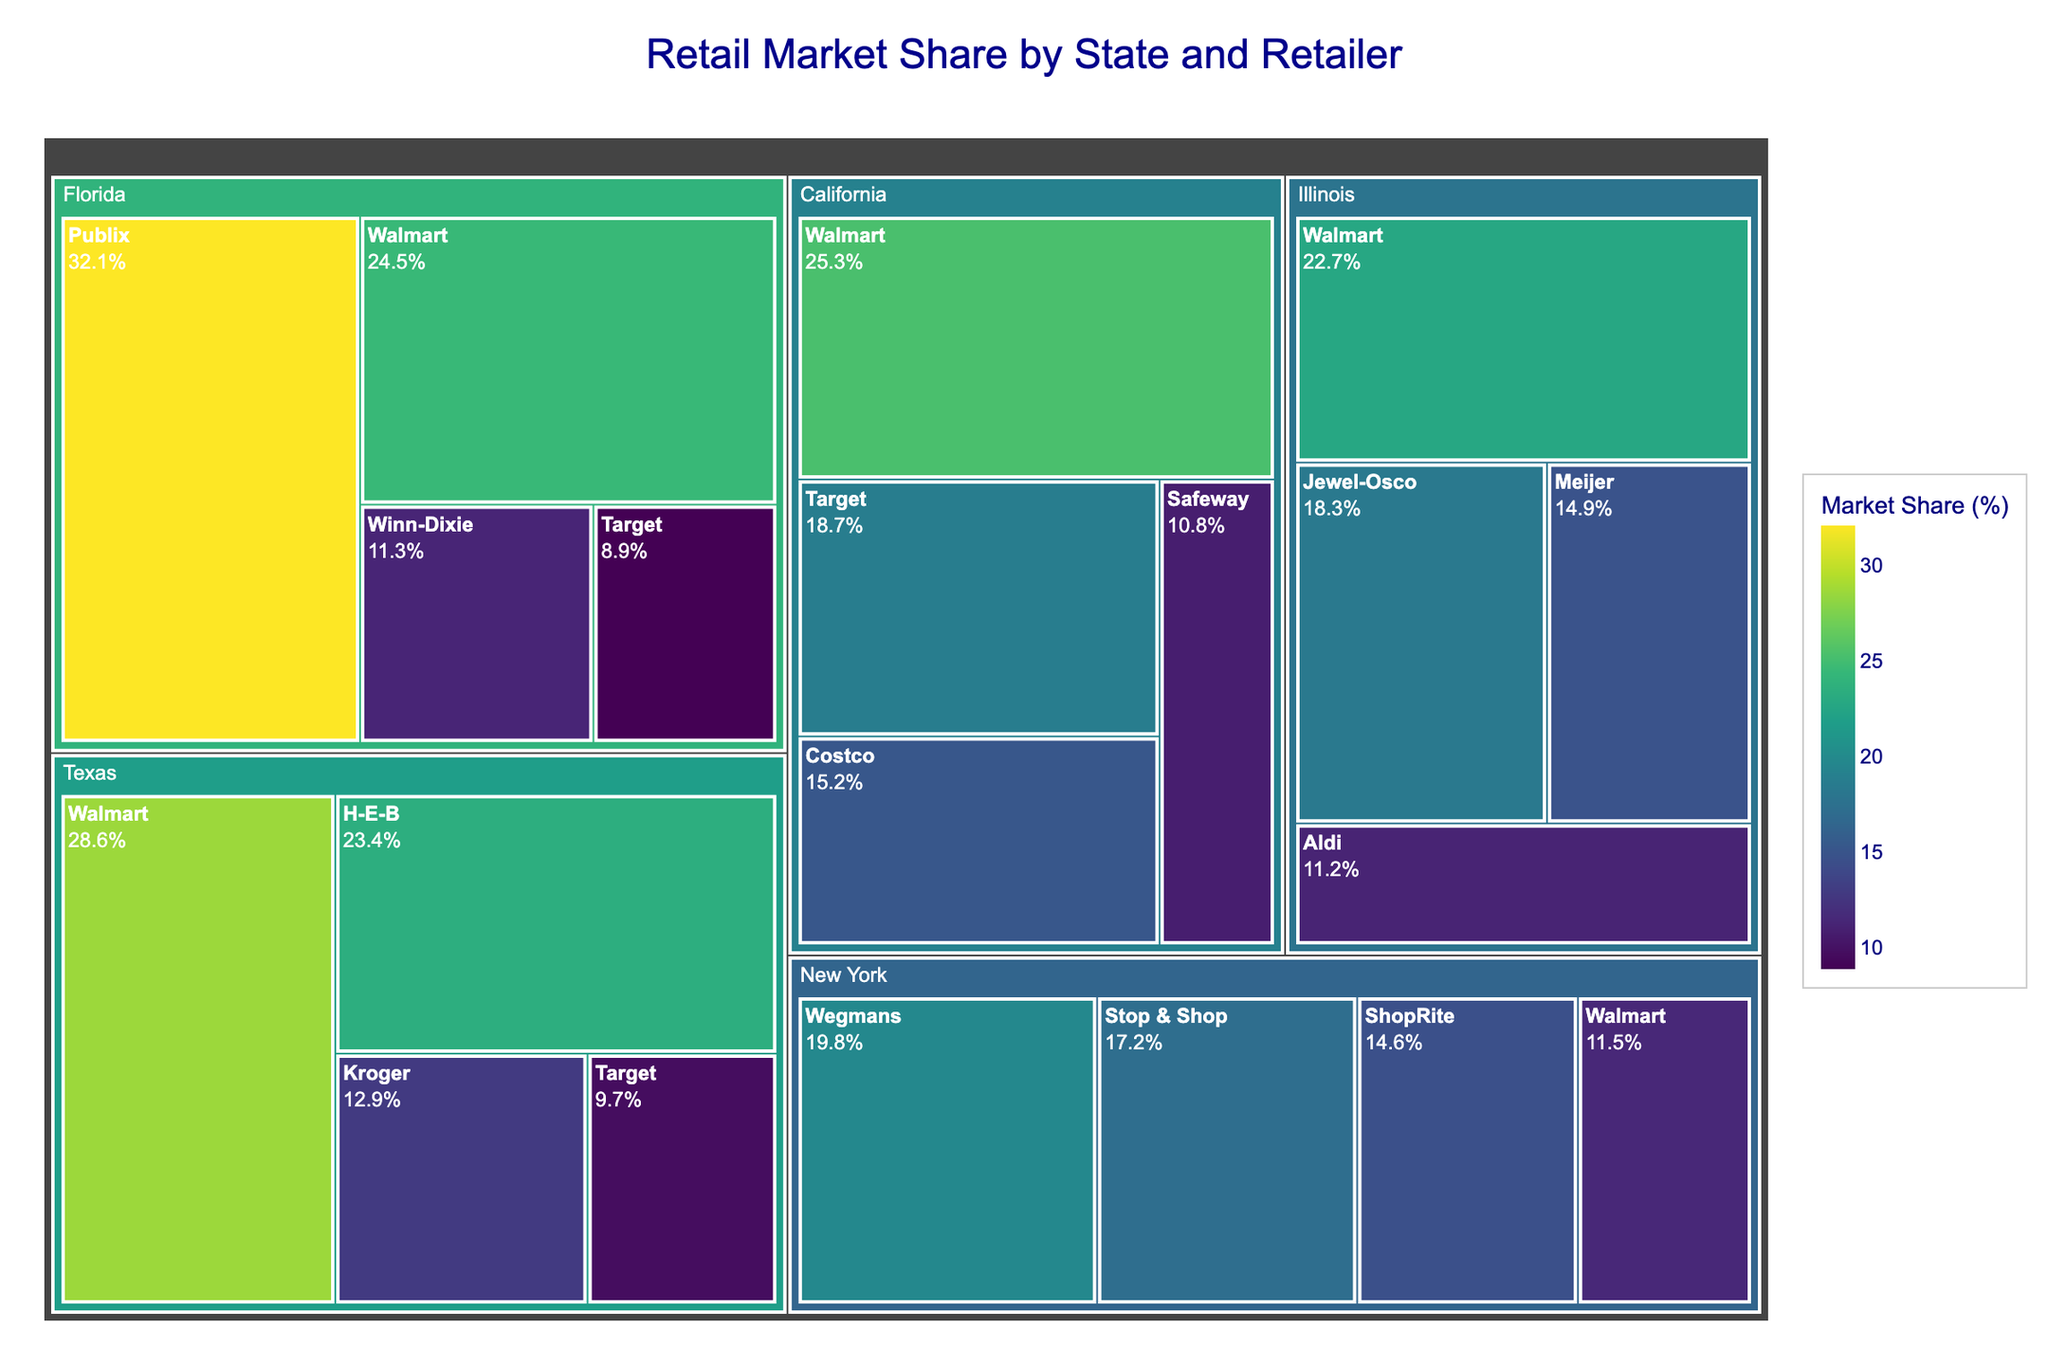What is the title of the treemap? The title of the treemap is usually positioned at the top center of the figure. It indicates the main subject or theme of the visualization. In this case, the title is specified during the treemap creation and denotes the major focus of the data presented.
Answer: Retail Market Share by State and Retailer Which retailer has the largest market share in Texas? To determine this, locate the segment for Texas in the treemap. Among the retailers listed for Texas, the one with the largest area (and therefore the highest percentage) is the one with the largest market share.
Answer: Walmart What is the combined market share of Walmart in California and Texas? Identify the market share values of Walmart in both California and Texas from the treemap. Add these values together to get the combined market share. Calculation: 25.3% (California) + 28.6% (Texas) = 53.9%
Answer: 53.9% Which state has the retailer with the highest individual market share, and which retailer is it? Examine each state in the treemap to identify which state's segment contains the retailer with the largest single market share.
Answer: Florida, Publix How does the market share of Target in California compare to its market share in Texas? Find Target's segments in both California and Texas in the treemap. Compare the percentage values associated with each to see which is higher and by how much.
Answer: Target has a higher market share in California than in Texas by 9% In which state does a single retailer hold more than 30% market share? Review each state segment and check if any retailer within that state exceeds the 30% market share threshold.
Answer: Florida What is the difference in market share between Stop & Shop and ShopRite in New York? Locate the segments for Stop & Shop and ShopRite within the New York section of the treemap. Subtract the smaller market share from the larger market share. Calculation: 17.2% (Stop & Shop) - 14.6% (ShopRite) = 2.6%
Answer: 2.6% Which retailer appears in the most states? Identify the retailers listed under each state from the treemap. Count the number of states each retailer appears in to determine which is present in the most states.
Answer: Walmart What is the total market share of all retailers in Illinois listed in the treemap? Sum up the market share percentages of all the retailers listed under Illinois in the treemap. Calculation: 22.7% (Walmart) + 18.3% (Jewel-Osco) + 14.9% (Meijer) + 11.2% (Aldi) = 67.1%
Answer: 67.1% How do the market shares of Publix and Walmart in Florida compare? Find the segments for Publix and Walmart in the Florida section of the treemap. Compare their respective market share values to determine the difference. Publix has 32.1% and Walmart has 24.5%, so Publix has a higher market share.
Answer: Publix has a higher market share than Walmart by 7.6% 